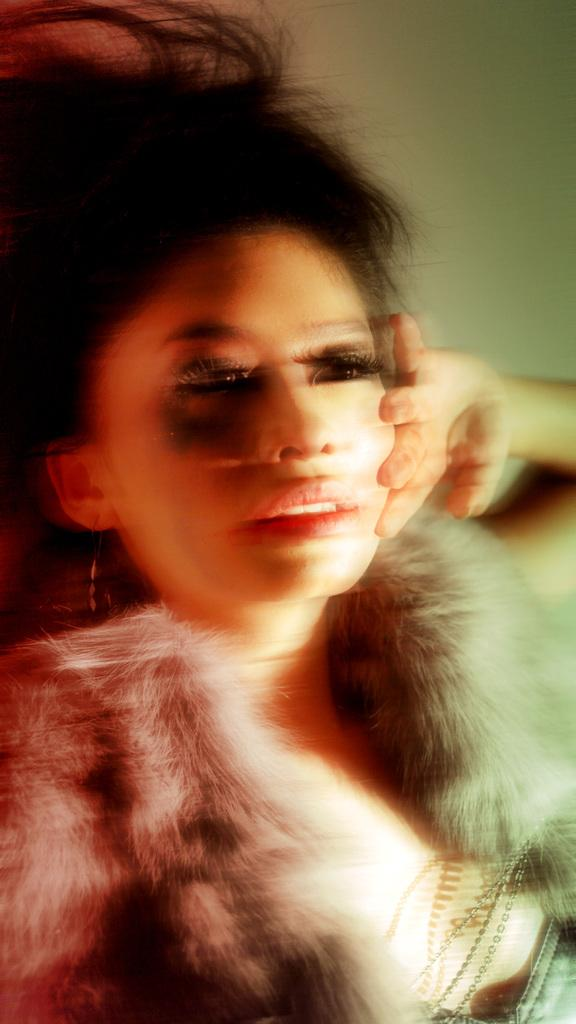Who is present in the image? There is a woman in the image. What type of accessory is the woman wearing? The woman is wearing earrings. What can be seen in the background of the image? There is a wall in the background of the image. What type of tank is visible in the image? There is no tank present in the image; it features a woman and a wall in the background. 